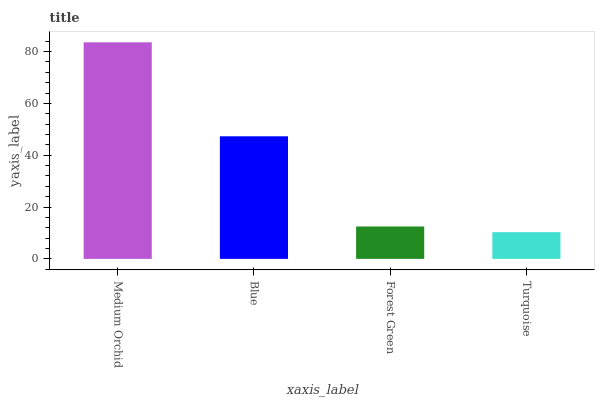Is Turquoise the minimum?
Answer yes or no. Yes. Is Medium Orchid the maximum?
Answer yes or no. Yes. Is Blue the minimum?
Answer yes or no. No. Is Blue the maximum?
Answer yes or no. No. Is Medium Orchid greater than Blue?
Answer yes or no. Yes. Is Blue less than Medium Orchid?
Answer yes or no. Yes. Is Blue greater than Medium Orchid?
Answer yes or no. No. Is Medium Orchid less than Blue?
Answer yes or no. No. Is Blue the high median?
Answer yes or no. Yes. Is Forest Green the low median?
Answer yes or no. Yes. Is Turquoise the high median?
Answer yes or no. No. Is Turquoise the low median?
Answer yes or no. No. 